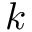<formula> <loc_0><loc_0><loc_500><loc_500>k</formula> 